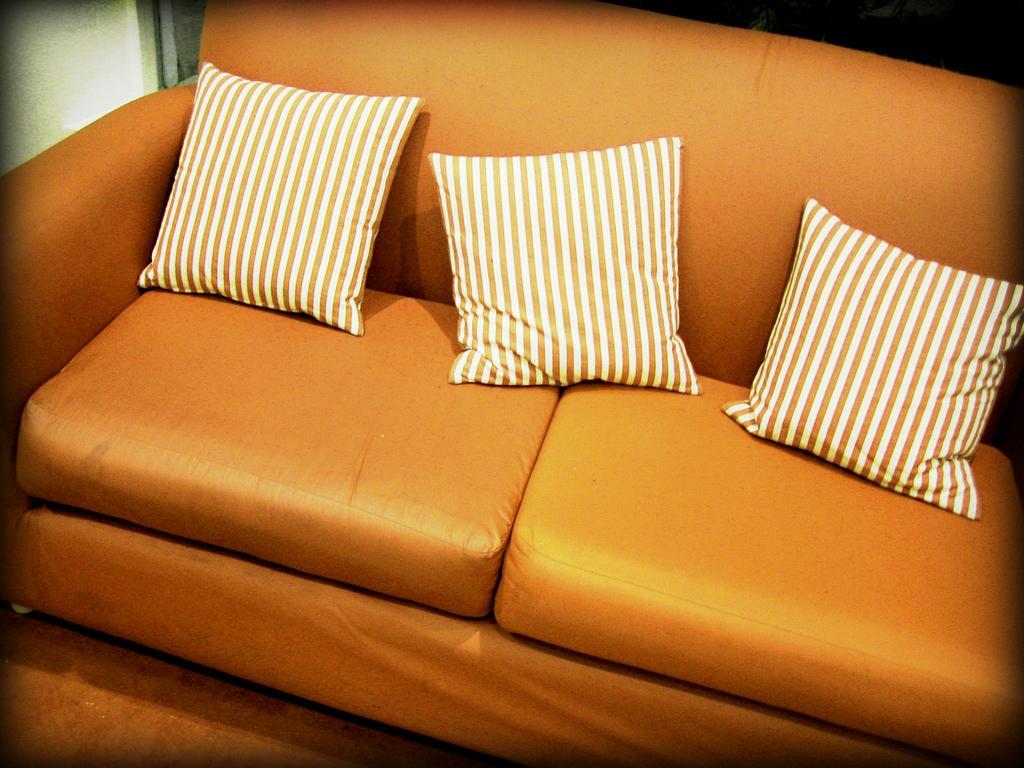Can you describe this image briefly? This picture is consists of a sofa which is orange in color and there are three pillows on it. 